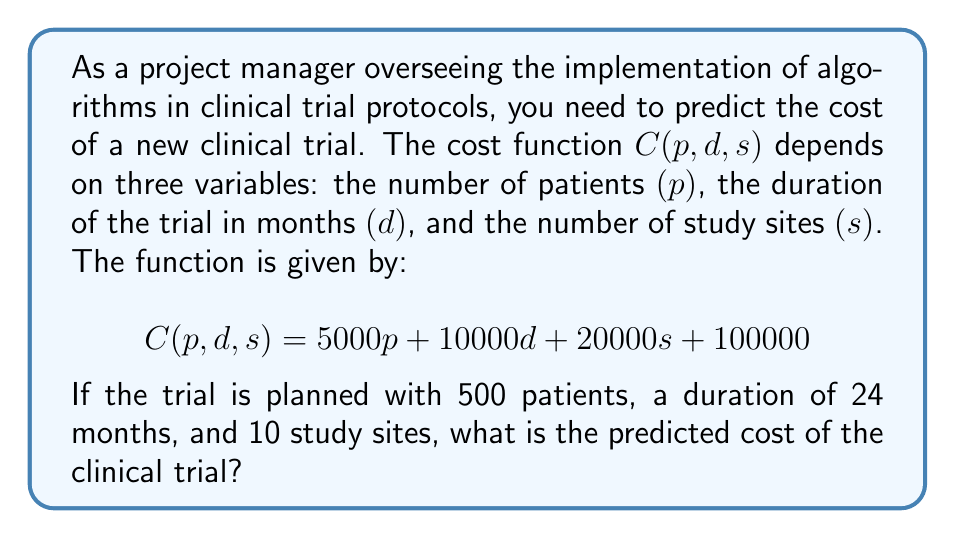Help me with this question. To solve this problem, we need to use the given multivariate function and substitute the values for each variable. Let's break it down step-by-step:

1. The cost function is given as:
   $$C(p, d, s) = 5000p + 10000d + 20000s + 100000$$

2. We are given the following values:
   - Number of patients $(p) = 500$
   - Duration of the trial $(d) = 24$ months
   - Number of study sites $(s) = 10$

3. Let's substitute these values into the function:
   $$C(500, 24, 10) = 5000(500) + 10000(24) + 20000(10) + 100000$$

4. Now, let's calculate each term:
   - $5000(500) = 2,500,000$
   - $10000(24) = 240,000$
   - $20000(10) = 200,000$
   - The constant term is $100,000$

5. Sum up all the terms:
   $$C(500, 24, 10) = 2,500,000 + 240,000 + 200,000 + 100,000$$

6. Perform the final addition:
   $$C(500, 24, 10) = 3,040,000$$

Therefore, the predicted cost of the clinical trial is $3,040,000.
Answer: $3,040,000 